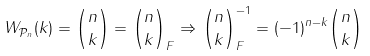<formula> <loc_0><loc_0><loc_500><loc_500>W _ { \mathcal { P } _ { n } } ( k ) = { n \choose k } = { n \choose k } _ { F } \Rightarrow { n \choose k } _ { F } ^ { - 1 } = ( - 1 ) ^ { n - k } { n \choose k }</formula> 